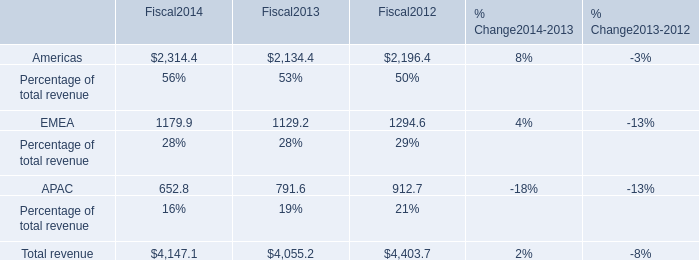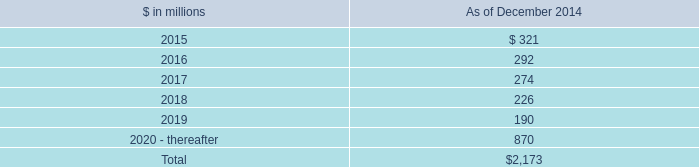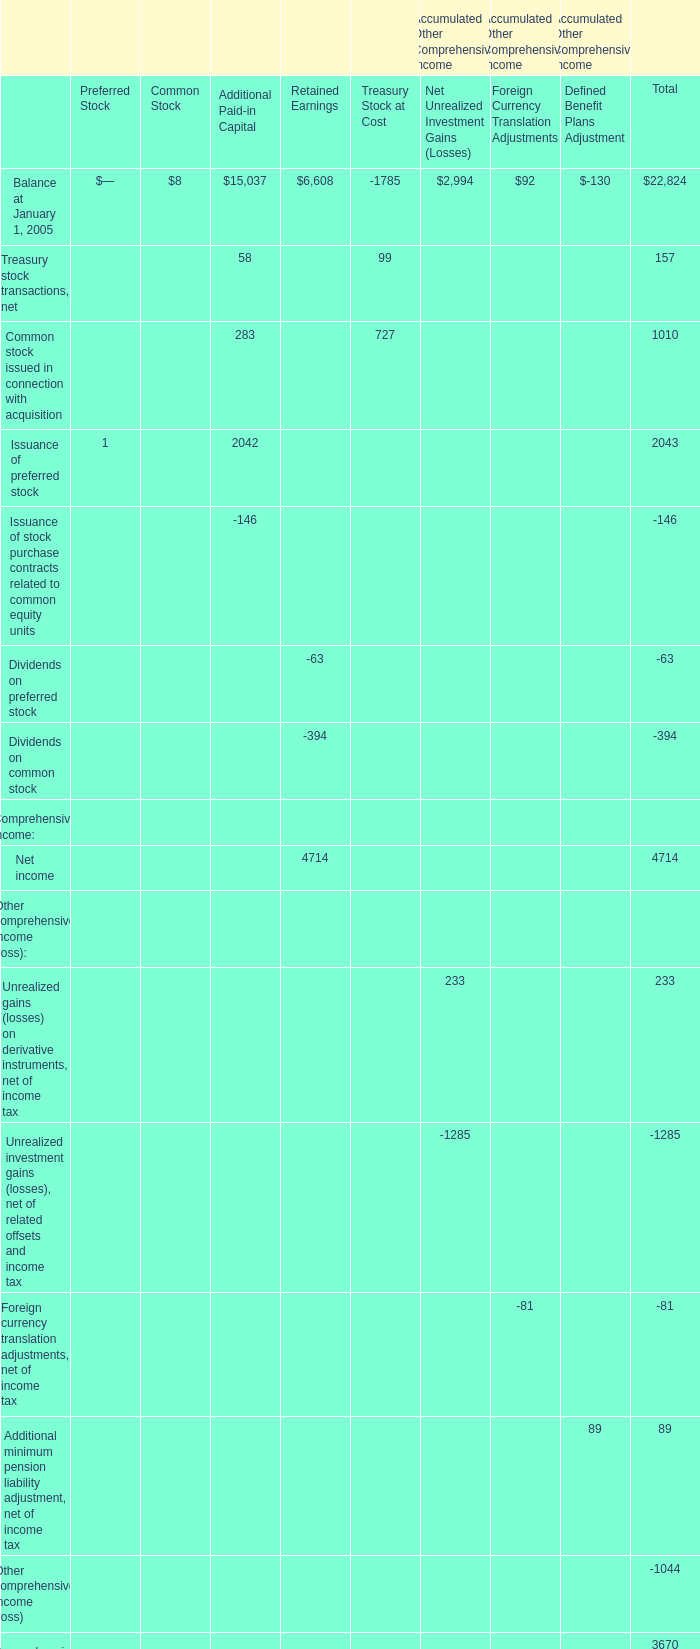What is the Net income for Retained Earnings in the year when the Balance for Retained Earnings on December 31 is greater than 19000? 
Answer: 4317. 